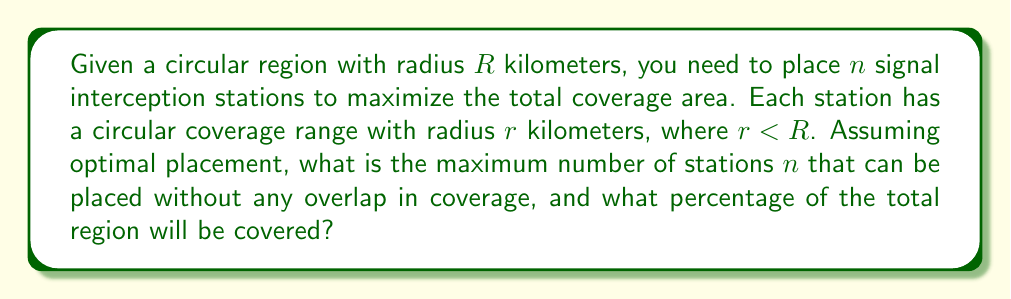Teach me how to tackle this problem. To solve this optimization problem, we need to follow these steps:

1) The optimal placement of circles within a larger circle is known as the circle packing problem. For maximum efficiency without overlap, the centers of the smaller circles should form a hexagonal lattice.

2) In a hexagonal lattice, each circle is surrounded by 6 other circles. The centers of these circles form equilateral triangles.

3) The side length of these equilateral triangles is $2r$, as the circles are just touching.

4) The area of an equilateral triangle with side length $2r$ is:

   $$A_{\triangle} = \frac{\sqrt{3}}{4}(2r)^2 = \sqrt{3}r^2$$

5) Each circle in the lattice (except those on the edge) is associated with 6 equilateral triangles, but each triangle is shared by 3 circles. So, the area associated with each circle is:

   $$A_{circle} = 2\sqrt{3}r^2$$

6) The number of circles (stations) that can fit is approximately:

   $$n \approx \frac{\pi R^2}{2\sqrt{3}r^2}$$

7) The actual number of stations must be an integer, so we round down:

   $$n = \left\lfloor\frac{\pi R^2}{2\sqrt{3}r^2}\right\rfloor$$

8) The total coverage area is:

   $$A_{coverage} = n\pi r^2$$

9) The percentage of the total region covered is:

   $$\text{Coverage %} = \frac{A_{coverage}}{\pi R^2} \times 100\% = \frac{n\pi r^2}{\pi R^2} \times 100\% = \frac{n r^2}{R^2} \times 100\%$$

10) Substituting the expression for $n$:

    $$\text{Coverage %} \approx \frac{\pi r^2}{2\sqrt{3}r^2} \times 100\% = \frac{\pi}{2\sqrt{3}} \times 100\% \approx 90.69\%$$

This is the theoretical maximum coverage. The actual coverage will be slightly less due to rounding down $n$ and edge effects.
Answer: The maximum number of stations $n$ that can be placed without overlap is:

$$n = \left\lfloor\frac{\pi R^2}{2\sqrt{3}r^2}\right\rfloor$$

The maximum percentage of the total region that can be covered is approximately 90.69%. 